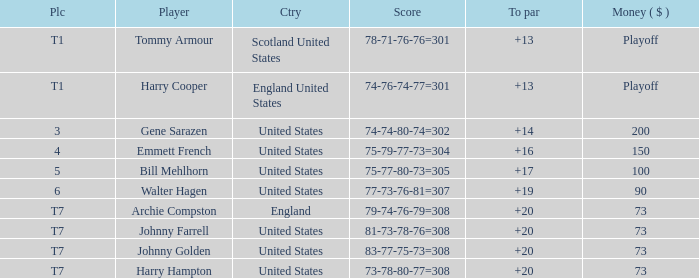Which country has a to par less than 19 and a score of 75-79-77-73=304? United States. 